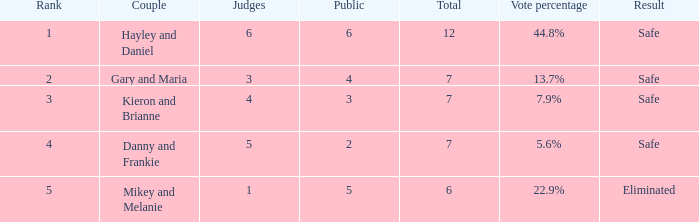What is the number of public that was there when the vote percentage was 22.9%? 1.0. 